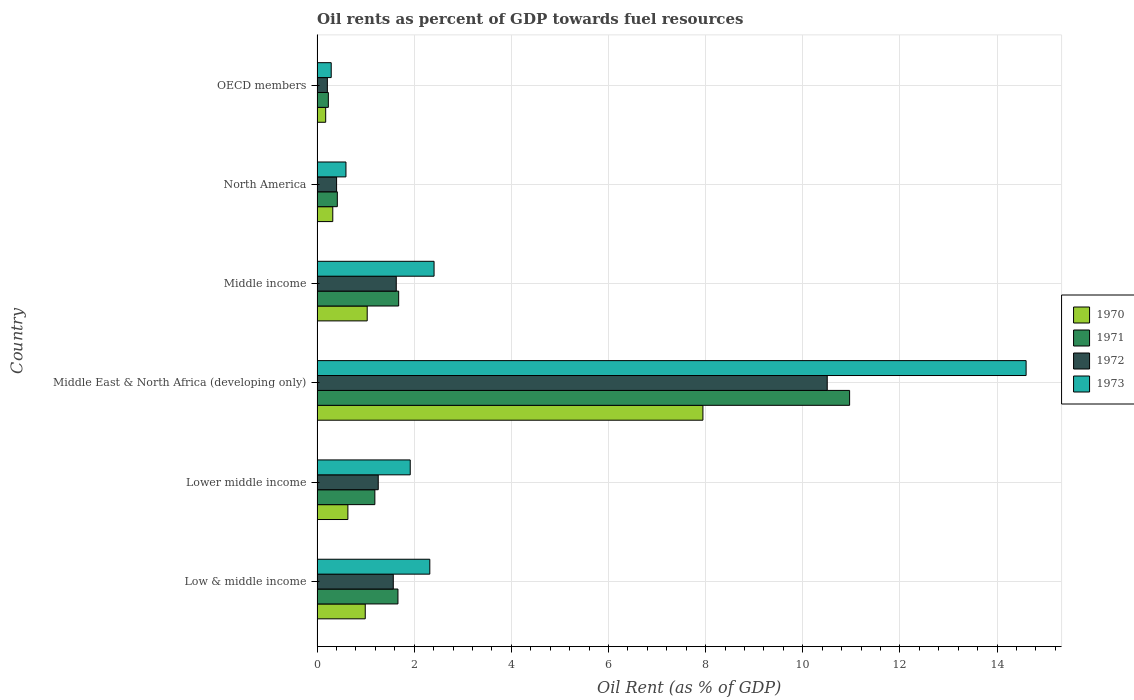How many different coloured bars are there?
Provide a succinct answer. 4. Are the number of bars per tick equal to the number of legend labels?
Provide a succinct answer. Yes. How many bars are there on the 3rd tick from the bottom?
Keep it short and to the point. 4. What is the label of the 1st group of bars from the top?
Offer a very short reply. OECD members. What is the oil rent in 1973 in Middle income?
Provide a succinct answer. 2.41. Across all countries, what is the maximum oil rent in 1970?
Offer a terse response. 7.94. Across all countries, what is the minimum oil rent in 1971?
Provide a short and direct response. 0.23. In which country was the oil rent in 1973 maximum?
Provide a short and direct response. Middle East & North Africa (developing only). What is the total oil rent in 1973 in the graph?
Your response must be concise. 22.13. What is the difference between the oil rent in 1972 in Middle East & North Africa (developing only) and that in OECD members?
Your answer should be compact. 10.29. What is the difference between the oil rent in 1973 in Lower middle income and the oil rent in 1972 in Low & middle income?
Provide a short and direct response. 0.35. What is the average oil rent in 1973 per country?
Your answer should be very brief. 3.69. What is the difference between the oil rent in 1972 and oil rent in 1970 in Low & middle income?
Your answer should be very brief. 0.58. In how many countries, is the oil rent in 1971 greater than 7.2 %?
Your answer should be compact. 1. What is the ratio of the oil rent in 1972 in Lower middle income to that in Middle income?
Keep it short and to the point. 0.77. What is the difference between the highest and the second highest oil rent in 1971?
Your answer should be very brief. 9.28. What is the difference between the highest and the lowest oil rent in 1972?
Your answer should be very brief. 10.29. In how many countries, is the oil rent in 1972 greater than the average oil rent in 1972 taken over all countries?
Your answer should be compact. 1. Is the sum of the oil rent in 1971 in Middle East & North Africa (developing only) and OECD members greater than the maximum oil rent in 1972 across all countries?
Keep it short and to the point. Yes. What does the 4th bar from the top in Lower middle income represents?
Offer a very short reply. 1970. Are all the bars in the graph horizontal?
Offer a terse response. Yes. What is the difference between two consecutive major ticks on the X-axis?
Your response must be concise. 2. Where does the legend appear in the graph?
Provide a short and direct response. Center right. What is the title of the graph?
Offer a very short reply. Oil rents as percent of GDP towards fuel resources. Does "2006" appear as one of the legend labels in the graph?
Ensure brevity in your answer.  No. What is the label or title of the X-axis?
Provide a succinct answer. Oil Rent (as % of GDP). What is the Oil Rent (as % of GDP) in 1970 in Low & middle income?
Provide a short and direct response. 0.99. What is the Oil Rent (as % of GDP) of 1971 in Low & middle income?
Provide a succinct answer. 1.67. What is the Oil Rent (as % of GDP) in 1972 in Low & middle income?
Your response must be concise. 1.57. What is the Oil Rent (as % of GDP) of 1973 in Low & middle income?
Provide a short and direct response. 2.32. What is the Oil Rent (as % of GDP) in 1970 in Lower middle income?
Your answer should be very brief. 0.63. What is the Oil Rent (as % of GDP) in 1971 in Lower middle income?
Offer a terse response. 1.19. What is the Oil Rent (as % of GDP) in 1972 in Lower middle income?
Offer a very short reply. 1.26. What is the Oil Rent (as % of GDP) of 1973 in Lower middle income?
Your answer should be very brief. 1.92. What is the Oil Rent (as % of GDP) of 1970 in Middle East & North Africa (developing only)?
Offer a terse response. 7.94. What is the Oil Rent (as % of GDP) in 1971 in Middle East & North Africa (developing only)?
Your answer should be compact. 10.96. What is the Oil Rent (as % of GDP) of 1972 in Middle East & North Africa (developing only)?
Offer a terse response. 10.5. What is the Oil Rent (as % of GDP) in 1973 in Middle East & North Africa (developing only)?
Your answer should be compact. 14.6. What is the Oil Rent (as % of GDP) in 1970 in Middle income?
Ensure brevity in your answer.  1.03. What is the Oil Rent (as % of GDP) in 1971 in Middle income?
Your answer should be compact. 1.68. What is the Oil Rent (as % of GDP) of 1972 in Middle income?
Your answer should be very brief. 1.63. What is the Oil Rent (as % of GDP) in 1973 in Middle income?
Provide a succinct answer. 2.41. What is the Oil Rent (as % of GDP) of 1970 in North America?
Your answer should be compact. 0.32. What is the Oil Rent (as % of GDP) in 1971 in North America?
Your answer should be very brief. 0.42. What is the Oil Rent (as % of GDP) in 1972 in North America?
Your answer should be very brief. 0.4. What is the Oil Rent (as % of GDP) in 1973 in North America?
Your answer should be compact. 0.6. What is the Oil Rent (as % of GDP) in 1970 in OECD members?
Offer a terse response. 0.18. What is the Oil Rent (as % of GDP) of 1971 in OECD members?
Provide a succinct answer. 0.23. What is the Oil Rent (as % of GDP) of 1972 in OECD members?
Give a very brief answer. 0.21. What is the Oil Rent (as % of GDP) in 1973 in OECD members?
Offer a very short reply. 0.29. Across all countries, what is the maximum Oil Rent (as % of GDP) of 1970?
Your answer should be very brief. 7.94. Across all countries, what is the maximum Oil Rent (as % of GDP) in 1971?
Provide a short and direct response. 10.96. Across all countries, what is the maximum Oil Rent (as % of GDP) in 1972?
Make the answer very short. 10.5. Across all countries, what is the maximum Oil Rent (as % of GDP) in 1973?
Offer a very short reply. 14.6. Across all countries, what is the minimum Oil Rent (as % of GDP) in 1970?
Give a very brief answer. 0.18. Across all countries, what is the minimum Oil Rent (as % of GDP) of 1971?
Your answer should be very brief. 0.23. Across all countries, what is the minimum Oil Rent (as % of GDP) in 1972?
Your response must be concise. 0.21. Across all countries, what is the minimum Oil Rent (as % of GDP) in 1973?
Your response must be concise. 0.29. What is the total Oil Rent (as % of GDP) in 1970 in the graph?
Keep it short and to the point. 11.1. What is the total Oil Rent (as % of GDP) of 1971 in the graph?
Your response must be concise. 16.15. What is the total Oil Rent (as % of GDP) of 1972 in the graph?
Your answer should be very brief. 15.58. What is the total Oil Rent (as % of GDP) of 1973 in the graph?
Make the answer very short. 22.13. What is the difference between the Oil Rent (as % of GDP) of 1970 in Low & middle income and that in Lower middle income?
Provide a succinct answer. 0.36. What is the difference between the Oil Rent (as % of GDP) of 1971 in Low & middle income and that in Lower middle income?
Provide a succinct answer. 0.48. What is the difference between the Oil Rent (as % of GDP) of 1972 in Low & middle income and that in Lower middle income?
Ensure brevity in your answer.  0.31. What is the difference between the Oil Rent (as % of GDP) in 1973 in Low & middle income and that in Lower middle income?
Your response must be concise. 0.4. What is the difference between the Oil Rent (as % of GDP) of 1970 in Low & middle income and that in Middle East & North Africa (developing only)?
Make the answer very short. -6.95. What is the difference between the Oil Rent (as % of GDP) in 1971 in Low & middle income and that in Middle East & North Africa (developing only)?
Ensure brevity in your answer.  -9.3. What is the difference between the Oil Rent (as % of GDP) of 1972 in Low & middle income and that in Middle East & North Africa (developing only)?
Ensure brevity in your answer.  -8.93. What is the difference between the Oil Rent (as % of GDP) in 1973 in Low & middle income and that in Middle East & North Africa (developing only)?
Offer a very short reply. -12.28. What is the difference between the Oil Rent (as % of GDP) in 1970 in Low & middle income and that in Middle income?
Provide a succinct answer. -0.04. What is the difference between the Oil Rent (as % of GDP) in 1971 in Low & middle income and that in Middle income?
Keep it short and to the point. -0.01. What is the difference between the Oil Rent (as % of GDP) of 1972 in Low & middle income and that in Middle income?
Offer a terse response. -0.06. What is the difference between the Oil Rent (as % of GDP) in 1973 in Low & middle income and that in Middle income?
Keep it short and to the point. -0.09. What is the difference between the Oil Rent (as % of GDP) in 1970 in Low & middle income and that in North America?
Make the answer very short. 0.67. What is the difference between the Oil Rent (as % of GDP) of 1971 in Low & middle income and that in North America?
Give a very brief answer. 1.25. What is the difference between the Oil Rent (as % of GDP) of 1972 in Low & middle income and that in North America?
Offer a very short reply. 1.17. What is the difference between the Oil Rent (as % of GDP) of 1973 in Low & middle income and that in North America?
Your response must be concise. 1.73. What is the difference between the Oil Rent (as % of GDP) in 1970 in Low & middle income and that in OECD members?
Make the answer very short. 0.81. What is the difference between the Oil Rent (as % of GDP) of 1971 in Low & middle income and that in OECD members?
Your answer should be compact. 1.43. What is the difference between the Oil Rent (as % of GDP) in 1972 in Low & middle income and that in OECD members?
Your answer should be very brief. 1.36. What is the difference between the Oil Rent (as % of GDP) in 1973 in Low & middle income and that in OECD members?
Your response must be concise. 2.03. What is the difference between the Oil Rent (as % of GDP) of 1970 in Lower middle income and that in Middle East & North Africa (developing only)?
Your response must be concise. -7.31. What is the difference between the Oil Rent (as % of GDP) of 1971 in Lower middle income and that in Middle East & North Africa (developing only)?
Provide a short and direct response. -9.77. What is the difference between the Oil Rent (as % of GDP) in 1972 in Lower middle income and that in Middle East & North Africa (developing only)?
Provide a succinct answer. -9.24. What is the difference between the Oil Rent (as % of GDP) of 1973 in Lower middle income and that in Middle East & North Africa (developing only)?
Make the answer very short. -12.68. What is the difference between the Oil Rent (as % of GDP) of 1970 in Lower middle income and that in Middle income?
Your response must be concise. -0.4. What is the difference between the Oil Rent (as % of GDP) in 1971 in Lower middle income and that in Middle income?
Ensure brevity in your answer.  -0.49. What is the difference between the Oil Rent (as % of GDP) of 1972 in Lower middle income and that in Middle income?
Keep it short and to the point. -0.37. What is the difference between the Oil Rent (as % of GDP) in 1973 in Lower middle income and that in Middle income?
Your answer should be compact. -0.49. What is the difference between the Oil Rent (as % of GDP) of 1970 in Lower middle income and that in North America?
Keep it short and to the point. 0.31. What is the difference between the Oil Rent (as % of GDP) of 1971 in Lower middle income and that in North America?
Offer a terse response. 0.77. What is the difference between the Oil Rent (as % of GDP) in 1972 in Lower middle income and that in North America?
Give a very brief answer. 0.86. What is the difference between the Oil Rent (as % of GDP) of 1973 in Lower middle income and that in North America?
Your response must be concise. 1.32. What is the difference between the Oil Rent (as % of GDP) in 1970 in Lower middle income and that in OECD members?
Your response must be concise. 0.46. What is the difference between the Oil Rent (as % of GDP) of 1971 in Lower middle income and that in OECD members?
Make the answer very short. 0.96. What is the difference between the Oil Rent (as % of GDP) in 1972 in Lower middle income and that in OECD members?
Ensure brevity in your answer.  1.05. What is the difference between the Oil Rent (as % of GDP) in 1973 in Lower middle income and that in OECD members?
Keep it short and to the point. 1.63. What is the difference between the Oil Rent (as % of GDP) in 1970 in Middle East & North Africa (developing only) and that in Middle income?
Ensure brevity in your answer.  6.91. What is the difference between the Oil Rent (as % of GDP) of 1971 in Middle East & North Africa (developing only) and that in Middle income?
Your answer should be compact. 9.28. What is the difference between the Oil Rent (as % of GDP) of 1972 in Middle East & North Africa (developing only) and that in Middle income?
Provide a short and direct response. 8.87. What is the difference between the Oil Rent (as % of GDP) of 1973 in Middle East & North Africa (developing only) and that in Middle income?
Give a very brief answer. 12.19. What is the difference between the Oil Rent (as % of GDP) in 1970 in Middle East & North Africa (developing only) and that in North America?
Offer a very short reply. 7.62. What is the difference between the Oil Rent (as % of GDP) in 1971 in Middle East & North Africa (developing only) and that in North America?
Keep it short and to the point. 10.55. What is the difference between the Oil Rent (as % of GDP) of 1972 in Middle East & North Africa (developing only) and that in North America?
Give a very brief answer. 10.1. What is the difference between the Oil Rent (as % of GDP) in 1973 in Middle East & North Africa (developing only) and that in North America?
Provide a short and direct response. 14. What is the difference between the Oil Rent (as % of GDP) of 1970 in Middle East & North Africa (developing only) and that in OECD members?
Offer a very short reply. 7.77. What is the difference between the Oil Rent (as % of GDP) in 1971 in Middle East & North Africa (developing only) and that in OECD members?
Offer a terse response. 10.73. What is the difference between the Oil Rent (as % of GDP) in 1972 in Middle East & North Africa (developing only) and that in OECD members?
Your answer should be compact. 10.29. What is the difference between the Oil Rent (as % of GDP) of 1973 in Middle East & North Africa (developing only) and that in OECD members?
Offer a very short reply. 14.3. What is the difference between the Oil Rent (as % of GDP) of 1970 in Middle income and that in North America?
Your answer should be very brief. 0.71. What is the difference between the Oil Rent (as % of GDP) of 1971 in Middle income and that in North America?
Your response must be concise. 1.26. What is the difference between the Oil Rent (as % of GDP) in 1972 in Middle income and that in North America?
Make the answer very short. 1.23. What is the difference between the Oil Rent (as % of GDP) of 1973 in Middle income and that in North America?
Provide a short and direct response. 1.81. What is the difference between the Oil Rent (as % of GDP) in 1970 in Middle income and that in OECD members?
Offer a very short reply. 0.85. What is the difference between the Oil Rent (as % of GDP) in 1971 in Middle income and that in OECD members?
Your response must be concise. 1.45. What is the difference between the Oil Rent (as % of GDP) of 1972 in Middle income and that in OECD members?
Offer a very short reply. 1.42. What is the difference between the Oil Rent (as % of GDP) in 1973 in Middle income and that in OECD members?
Keep it short and to the point. 2.12. What is the difference between the Oil Rent (as % of GDP) of 1970 in North America and that in OECD members?
Your response must be concise. 0.15. What is the difference between the Oil Rent (as % of GDP) of 1971 in North America and that in OECD members?
Offer a terse response. 0.18. What is the difference between the Oil Rent (as % of GDP) of 1972 in North America and that in OECD members?
Your answer should be compact. 0.19. What is the difference between the Oil Rent (as % of GDP) in 1973 in North America and that in OECD members?
Your answer should be very brief. 0.3. What is the difference between the Oil Rent (as % of GDP) of 1970 in Low & middle income and the Oil Rent (as % of GDP) of 1971 in Lower middle income?
Give a very brief answer. -0.2. What is the difference between the Oil Rent (as % of GDP) of 1970 in Low & middle income and the Oil Rent (as % of GDP) of 1972 in Lower middle income?
Provide a short and direct response. -0.27. What is the difference between the Oil Rent (as % of GDP) in 1970 in Low & middle income and the Oil Rent (as % of GDP) in 1973 in Lower middle income?
Your response must be concise. -0.93. What is the difference between the Oil Rent (as % of GDP) of 1971 in Low & middle income and the Oil Rent (as % of GDP) of 1972 in Lower middle income?
Your answer should be very brief. 0.41. What is the difference between the Oil Rent (as % of GDP) of 1971 in Low & middle income and the Oil Rent (as % of GDP) of 1973 in Lower middle income?
Ensure brevity in your answer.  -0.25. What is the difference between the Oil Rent (as % of GDP) of 1972 in Low & middle income and the Oil Rent (as % of GDP) of 1973 in Lower middle income?
Provide a succinct answer. -0.35. What is the difference between the Oil Rent (as % of GDP) of 1970 in Low & middle income and the Oil Rent (as % of GDP) of 1971 in Middle East & North Africa (developing only)?
Ensure brevity in your answer.  -9.97. What is the difference between the Oil Rent (as % of GDP) of 1970 in Low & middle income and the Oil Rent (as % of GDP) of 1972 in Middle East & North Africa (developing only)?
Offer a very short reply. -9.51. What is the difference between the Oil Rent (as % of GDP) in 1970 in Low & middle income and the Oil Rent (as % of GDP) in 1973 in Middle East & North Africa (developing only)?
Keep it short and to the point. -13.6. What is the difference between the Oil Rent (as % of GDP) of 1971 in Low & middle income and the Oil Rent (as % of GDP) of 1972 in Middle East & North Africa (developing only)?
Your response must be concise. -8.84. What is the difference between the Oil Rent (as % of GDP) in 1971 in Low & middle income and the Oil Rent (as % of GDP) in 1973 in Middle East & North Africa (developing only)?
Offer a very short reply. -12.93. What is the difference between the Oil Rent (as % of GDP) of 1972 in Low & middle income and the Oil Rent (as % of GDP) of 1973 in Middle East & North Africa (developing only)?
Keep it short and to the point. -13.03. What is the difference between the Oil Rent (as % of GDP) of 1970 in Low & middle income and the Oil Rent (as % of GDP) of 1971 in Middle income?
Your response must be concise. -0.69. What is the difference between the Oil Rent (as % of GDP) in 1970 in Low & middle income and the Oil Rent (as % of GDP) in 1972 in Middle income?
Your response must be concise. -0.64. What is the difference between the Oil Rent (as % of GDP) of 1970 in Low & middle income and the Oil Rent (as % of GDP) of 1973 in Middle income?
Your response must be concise. -1.42. What is the difference between the Oil Rent (as % of GDP) in 1971 in Low & middle income and the Oil Rent (as % of GDP) in 1972 in Middle income?
Provide a short and direct response. 0.03. What is the difference between the Oil Rent (as % of GDP) of 1971 in Low & middle income and the Oil Rent (as % of GDP) of 1973 in Middle income?
Make the answer very short. -0.74. What is the difference between the Oil Rent (as % of GDP) of 1972 in Low & middle income and the Oil Rent (as % of GDP) of 1973 in Middle income?
Provide a short and direct response. -0.84. What is the difference between the Oil Rent (as % of GDP) in 1970 in Low & middle income and the Oil Rent (as % of GDP) in 1971 in North America?
Offer a terse response. 0.57. What is the difference between the Oil Rent (as % of GDP) of 1970 in Low & middle income and the Oil Rent (as % of GDP) of 1972 in North America?
Your answer should be very brief. 0.59. What is the difference between the Oil Rent (as % of GDP) of 1970 in Low & middle income and the Oil Rent (as % of GDP) of 1973 in North America?
Make the answer very short. 0.4. What is the difference between the Oil Rent (as % of GDP) in 1971 in Low & middle income and the Oil Rent (as % of GDP) in 1972 in North America?
Make the answer very short. 1.26. What is the difference between the Oil Rent (as % of GDP) in 1971 in Low & middle income and the Oil Rent (as % of GDP) in 1973 in North America?
Give a very brief answer. 1.07. What is the difference between the Oil Rent (as % of GDP) of 1972 in Low & middle income and the Oil Rent (as % of GDP) of 1973 in North America?
Your response must be concise. 0.97. What is the difference between the Oil Rent (as % of GDP) in 1970 in Low & middle income and the Oil Rent (as % of GDP) in 1971 in OECD members?
Ensure brevity in your answer.  0.76. What is the difference between the Oil Rent (as % of GDP) in 1970 in Low & middle income and the Oil Rent (as % of GDP) in 1972 in OECD members?
Provide a short and direct response. 0.78. What is the difference between the Oil Rent (as % of GDP) of 1970 in Low & middle income and the Oil Rent (as % of GDP) of 1973 in OECD members?
Make the answer very short. 0.7. What is the difference between the Oil Rent (as % of GDP) of 1971 in Low & middle income and the Oil Rent (as % of GDP) of 1972 in OECD members?
Make the answer very short. 1.45. What is the difference between the Oil Rent (as % of GDP) in 1971 in Low & middle income and the Oil Rent (as % of GDP) in 1973 in OECD members?
Your answer should be compact. 1.37. What is the difference between the Oil Rent (as % of GDP) in 1972 in Low & middle income and the Oil Rent (as % of GDP) in 1973 in OECD members?
Offer a very short reply. 1.28. What is the difference between the Oil Rent (as % of GDP) of 1970 in Lower middle income and the Oil Rent (as % of GDP) of 1971 in Middle East & North Africa (developing only)?
Offer a terse response. -10.33. What is the difference between the Oil Rent (as % of GDP) in 1970 in Lower middle income and the Oil Rent (as % of GDP) in 1972 in Middle East & North Africa (developing only)?
Your response must be concise. -9.87. What is the difference between the Oil Rent (as % of GDP) in 1970 in Lower middle income and the Oil Rent (as % of GDP) in 1973 in Middle East & North Africa (developing only)?
Keep it short and to the point. -13.96. What is the difference between the Oil Rent (as % of GDP) in 1971 in Lower middle income and the Oil Rent (as % of GDP) in 1972 in Middle East & North Africa (developing only)?
Make the answer very short. -9.31. What is the difference between the Oil Rent (as % of GDP) in 1971 in Lower middle income and the Oil Rent (as % of GDP) in 1973 in Middle East & North Africa (developing only)?
Offer a terse response. -13.41. What is the difference between the Oil Rent (as % of GDP) in 1972 in Lower middle income and the Oil Rent (as % of GDP) in 1973 in Middle East & North Africa (developing only)?
Offer a terse response. -13.34. What is the difference between the Oil Rent (as % of GDP) in 1970 in Lower middle income and the Oil Rent (as % of GDP) in 1971 in Middle income?
Your answer should be very brief. -1.05. What is the difference between the Oil Rent (as % of GDP) of 1970 in Lower middle income and the Oil Rent (as % of GDP) of 1972 in Middle income?
Offer a very short reply. -1. What is the difference between the Oil Rent (as % of GDP) of 1970 in Lower middle income and the Oil Rent (as % of GDP) of 1973 in Middle income?
Offer a terse response. -1.77. What is the difference between the Oil Rent (as % of GDP) of 1971 in Lower middle income and the Oil Rent (as % of GDP) of 1972 in Middle income?
Offer a very short reply. -0.44. What is the difference between the Oil Rent (as % of GDP) in 1971 in Lower middle income and the Oil Rent (as % of GDP) in 1973 in Middle income?
Keep it short and to the point. -1.22. What is the difference between the Oil Rent (as % of GDP) in 1972 in Lower middle income and the Oil Rent (as % of GDP) in 1973 in Middle income?
Provide a short and direct response. -1.15. What is the difference between the Oil Rent (as % of GDP) in 1970 in Lower middle income and the Oil Rent (as % of GDP) in 1971 in North America?
Keep it short and to the point. 0.22. What is the difference between the Oil Rent (as % of GDP) in 1970 in Lower middle income and the Oil Rent (as % of GDP) in 1972 in North America?
Your answer should be very brief. 0.23. What is the difference between the Oil Rent (as % of GDP) of 1970 in Lower middle income and the Oil Rent (as % of GDP) of 1973 in North America?
Offer a very short reply. 0.04. What is the difference between the Oil Rent (as % of GDP) in 1971 in Lower middle income and the Oil Rent (as % of GDP) in 1972 in North America?
Offer a very short reply. 0.79. What is the difference between the Oil Rent (as % of GDP) in 1971 in Lower middle income and the Oil Rent (as % of GDP) in 1973 in North America?
Ensure brevity in your answer.  0.6. What is the difference between the Oil Rent (as % of GDP) of 1972 in Lower middle income and the Oil Rent (as % of GDP) of 1973 in North America?
Provide a short and direct response. 0.66. What is the difference between the Oil Rent (as % of GDP) in 1970 in Lower middle income and the Oil Rent (as % of GDP) in 1971 in OECD members?
Provide a succinct answer. 0.4. What is the difference between the Oil Rent (as % of GDP) of 1970 in Lower middle income and the Oil Rent (as % of GDP) of 1972 in OECD members?
Offer a terse response. 0.42. What is the difference between the Oil Rent (as % of GDP) of 1970 in Lower middle income and the Oil Rent (as % of GDP) of 1973 in OECD members?
Make the answer very short. 0.34. What is the difference between the Oil Rent (as % of GDP) of 1971 in Lower middle income and the Oil Rent (as % of GDP) of 1972 in OECD members?
Provide a short and direct response. 0.98. What is the difference between the Oil Rent (as % of GDP) in 1971 in Lower middle income and the Oil Rent (as % of GDP) in 1973 in OECD members?
Your answer should be very brief. 0.9. What is the difference between the Oil Rent (as % of GDP) of 1972 in Lower middle income and the Oil Rent (as % of GDP) of 1973 in OECD members?
Make the answer very short. 0.97. What is the difference between the Oil Rent (as % of GDP) of 1970 in Middle East & North Africa (developing only) and the Oil Rent (as % of GDP) of 1971 in Middle income?
Give a very brief answer. 6.26. What is the difference between the Oil Rent (as % of GDP) of 1970 in Middle East & North Africa (developing only) and the Oil Rent (as % of GDP) of 1972 in Middle income?
Your answer should be very brief. 6.31. What is the difference between the Oil Rent (as % of GDP) in 1970 in Middle East & North Africa (developing only) and the Oil Rent (as % of GDP) in 1973 in Middle income?
Give a very brief answer. 5.53. What is the difference between the Oil Rent (as % of GDP) in 1971 in Middle East & North Africa (developing only) and the Oil Rent (as % of GDP) in 1972 in Middle income?
Provide a succinct answer. 9.33. What is the difference between the Oil Rent (as % of GDP) of 1971 in Middle East & North Africa (developing only) and the Oil Rent (as % of GDP) of 1973 in Middle income?
Your response must be concise. 8.55. What is the difference between the Oil Rent (as % of GDP) of 1972 in Middle East & North Africa (developing only) and the Oil Rent (as % of GDP) of 1973 in Middle income?
Your answer should be very brief. 8.09. What is the difference between the Oil Rent (as % of GDP) in 1970 in Middle East & North Africa (developing only) and the Oil Rent (as % of GDP) in 1971 in North America?
Offer a terse response. 7.53. What is the difference between the Oil Rent (as % of GDP) of 1970 in Middle East & North Africa (developing only) and the Oil Rent (as % of GDP) of 1972 in North America?
Provide a short and direct response. 7.54. What is the difference between the Oil Rent (as % of GDP) of 1970 in Middle East & North Africa (developing only) and the Oil Rent (as % of GDP) of 1973 in North America?
Your answer should be very brief. 7.35. What is the difference between the Oil Rent (as % of GDP) in 1971 in Middle East & North Africa (developing only) and the Oil Rent (as % of GDP) in 1972 in North America?
Your answer should be compact. 10.56. What is the difference between the Oil Rent (as % of GDP) of 1971 in Middle East & North Africa (developing only) and the Oil Rent (as % of GDP) of 1973 in North America?
Ensure brevity in your answer.  10.37. What is the difference between the Oil Rent (as % of GDP) in 1972 in Middle East & North Africa (developing only) and the Oil Rent (as % of GDP) in 1973 in North America?
Your answer should be compact. 9.91. What is the difference between the Oil Rent (as % of GDP) of 1970 in Middle East & North Africa (developing only) and the Oil Rent (as % of GDP) of 1971 in OECD members?
Offer a very short reply. 7.71. What is the difference between the Oil Rent (as % of GDP) in 1970 in Middle East & North Africa (developing only) and the Oil Rent (as % of GDP) in 1972 in OECD members?
Give a very brief answer. 7.73. What is the difference between the Oil Rent (as % of GDP) in 1970 in Middle East & North Africa (developing only) and the Oil Rent (as % of GDP) in 1973 in OECD members?
Your answer should be very brief. 7.65. What is the difference between the Oil Rent (as % of GDP) of 1971 in Middle East & North Africa (developing only) and the Oil Rent (as % of GDP) of 1972 in OECD members?
Offer a very short reply. 10.75. What is the difference between the Oil Rent (as % of GDP) in 1971 in Middle East & North Africa (developing only) and the Oil Rent (as % of GDP) in 1973 in OECD members?
Your response must be concise. 10.67. What is the difference between the Oil Rent (as % of GDP) in 1972 in Middle East & North Africa (developing only) and the Oil Rent (as % of GDP) in 1973 in OECD members?
Give a very brief answer. 10.21. What is the difference between the Oil Rent (as % of GDP) in 1970 in Middle income and the Oil Rent (as % of GDP) in 1971 in North America?
Keep it short and to the point. 0.61. What is the difference between the Oil Rent (as % of GDP) in 1970 in Middle income and the Oil Rent (as % of GDP) in 1972 in North America?
Give a very brief answer. 0.63. What is the difference between the Oil Rent (as % of GDP) in 1970 in Middle income and the Oil Rent (as % of GDP) in 1973 in North America?
Keep it short and to the point. 0.44. What is the difference between the Oil Rent (as % of GDP) of 1971 in Middle income and the Oil Rent (as % of GDP) of 1972 in North America?
Ensure brevity in your answer.  1.28. What is the difference between the Oil Rent (as % of GDP) of 1971 in Middle income and the Oil Rent (as % of GDP) of 1973 in North America?
Your response must be concise. 1.09. What is the difference between the Oil Rent (as % of GDP) in 1972 in Middle income and the Oil Rent (as % of GDP) in 1973 in North America?
Provide a short and direct response. 1.04. What is the difference between the Oil Rent (as % of GDP) in 1970 in Middle income and the Oil Rent (as % of GDP) in 1971 in OECD members?
Offer a very short reply. 0.8. What is the difference between the Oil Rent (as % of GDP) of 1970 in Middle income and the Oil Rent (as % of GDP) of 1972 in OECD members?
Ensure brevity in your answer.  0.82. What is the difference between the Oil Rent (as % of GDP) in 1970 in Middle income and the Oil Rent (as % of GDP) in 1973 in OECD members?
Your answer should be very brief. 0.74. What is the difference between the Oil Rent (as % of GDP) in 1971 in Middle income and the Oil Rent (as % of GDP) in 1972 in OECD members?
Offer a very short reply. 1.47. What is the difference between the Oil Rent (as % of GDP) in 1971 in Middle income and the Oil Rent (as % of GDP) in 1973 in OECD members?
Give a very brief answer. 1.39. What is the difference between the Oil Rent (as % of GDP) in 1972 in Middle income and the Oil Rent (as % of GDP) in 1973 in OECD members?
Provide a short and direct response. 1.34. What is the difference between the Oil Rent (as % of GDP) in 1970 in North America and the Oil Rent (as % of GDP) in 1971 in OECD members?
Ensure brevity in your answer.  0.09. What is the difference between the Oil Rent (as % of GDP) of 1970 in North America and the Oil Rent (as % of GDP) of 1972 in OECD members?
Offer a very short reply. 0.11. What is the difference between the Oil Rent (as % of GDP) of 1970 in North America and the Oil Rent (as % of GDP) of 1973 in OECD members?
Offer a terse response. 0.03. What is the difference between the Oil Rent (as % of GDP) in 1971 in North America and the Oil Rent (as % of GDP) in 1972 in OECD members?
Provide a succinct answer. 0.21. What is the difference between the Oil Rent (as % of GDP) in 1971 in North America and the Oil Rent (as % of GDP) in 1973 in OECD members?
Make the answer very short. 0.13. What is the difference between the Oil Rent (as % of GDP) of 1972 in North America and the Oil Rent (as % of GDP) of 1973 in OECD members?
Your answer should be very brief. 0.11. What is the average Oil Rent (as % of GDP) of 1970 per country?
Provide a succinct answer. 1.85. What is the average Oil Rent (as % of GDP) in 1971 per country?
Your answer should be compact. 2.69. What is the average Oil Rent (as % of GDP) of 1972 per country?
Your response must be concise. 2.6. What is the average Oil Rent (as % of GDP) in 1973 per country?
Provide a succinct answer. 3.69. What is the difference between the Oil Rent (as % of GDP) of 1970 and Oil Rent (as % of GDP) of 1971 in Low & middle income?
Make the answer very short. -0.67. What is the difference between the Oil Rent (as % of GDP) of 1970 and Oil Rent (as % of GDP) of 1972 in Low & middle income?
Offer a very short reply. -0.58. What is the difference between the Oil Rent (as % of GDP) of 1970 and Oil Rent (as % of GDP) of 1973 in Low & middle income?
Give a very brief answer. -1.33. What is the difference between the Oil Rent (as % of GDP) of 1971 and Oil Rent (as % of GDP) of 1972 in Low & middle income?
Offer a terse response. 0.1. What is the difference between the Oil Rent (as % of GDP) in 1971 and Oil Rent (as % of GDP) in 1973 in Low & middle income?
Your response must be concise. -0.66. What is the difference between the Oil Rent (as % of GDP) of 1972 and Oil Rent (as % of GDP) of 1973 in Low & middle income?
Your answer should be compact. -0.75. What is the difference between the Oil Rent (as % of GDP) of 1970 and Oil Rent (as % of GDP) of 1971 in Lower middle income?
Keep it short and to the point. -0.56. What is the difference between the Oil Rent (as % of GDP) of 1970 and Oil Rent (as % of GDP) of 1972 in Lower middle income?
Your response must be concise. -0.62. What is the difference between the Oil Rent (as % of GDP) of 1970 and Oil Rent (as % of GDP) of 1973 in Lower middle income?
Your answer should be compact. -1.28. What is the difference between the Oil Rent (as % of GDP) in 1971 and Oil Rent (as % of GDP) in 1972 in Lower middle income?
Your response must be concise. -0.07. What is the difference between the Oil Rent (as % of GDP) in 1971 and Oil Rent (as % of GDP) in 1973 in Lower middle income?
Provide a short and direct response. -0.73. What is the difference between the Oil Rent (as % of GDP) of 1972 and Oil Rent (as % of GDP) of 1973 in Lower middle income?
Make the answer very short. -0.66. What is the difference between the Oil Rent (as % of GDP) in 1970 and Oil Rent (as % of GDP) in 1971 in Middle East & North Africa (developing only)?
Keep it short and to the point. -3.02. What is the difference between the Oil Rent (as % of GDP) of 1970 and Oil Rent (as % of GDP) of 1972 in Middle East & North Africa (developing only)?
Ensure brevity in your answer.  -2.56. What is the difference between the Oil Rent (as % of GDP) of 1970 and Oil Rent (as % of GDP) of 1973 in Middle East & North Africa (developing only)?
Provide a short and direct response. -6.65. What is the difference between the Oil Rent (as % of GDP) in 1971 and Oil Rent (as % of GDP) in 1972 in Middle East & North Africa (developing only)?
Your answer should be compact. 0.46. What is the difference between the Oil Rent (as % of GDP) of 1971 and Oil Rent (as % of GDP) of 1973 in Middle East & North Africa (developing only)?
Keep it short and to the point. -3.63. What is the difference between the Oil Rent (as % of GDP) of 1972 and Oil Rent (as % of GDP) of 1973 in Middle East & North Africa (developing only)?
Keep it short and to the point. -4.09. What is the difference between the Oil Rent (as % of GDP) in 1970 and Oil Rent (as % of GDP) in 1971 in Middle income?
Offer a very short reply. -0.65. What is the difference between the Oil Rent (as % of GDP) in 1970 and Oil Rent (as % of GDP) in 1972 in Middle income?
Offer a very short reply. -0.6. What is the difference between the Oil Rent (as % of GDP) in 1970 and Oil Rent (as % of GDP) in 1973 in Middle income?
Offer a very short reply. -1.38. What is the difference between the Oil Rent (as % of GDP) in 1971 and Oil Rent (as % of GDP) in 1972 in Middle income?
Your response must be concise. 0.05. What is the difference between the Oil Rent (as % of GDP) in 1971 and Oil Rent (as % of GDP) in 1973 in Middle income?
Your response must be concise. -0.73. What is the difference between the Oil Rent (as % of GDP) of 1972 and Oil Rent (as % of GDP) of 1973 in Middle income?
Keep it short and to the point. -0.78. What is the difference between the Oil Rent (as % of GDP) in 1970 and Oil Rent (as % of GDP) in 1971 in North America?
Offer a terse response. -0.09. What is the difference between the Oil Rent (as % of GDP) in 1970 and Oil Rent (as % of GDP) in 1972 in North America?
Your answer should be compact. -0.08. What is the difference between the Oil Rent (as % of GDP) in 1970 and Oil Rent (as % of GDP) in 1973 in North America?
Provide a short and direct response. -0.27. What is the difference between the Oil Rent (as % of GDP) in 1971 and Oil Rent (as % of GDP) in 1972 in North America?
Provide a succinct answer. 0.02. What is the difference between the Oil Rent (as % of GDP) of 1971 and Oil Rent (as % of GDP) of 1973 in North America?
Keep it short and to the point. -0.18. What is the difference between the Oil Rent (as % of GDP) of 1972 and Oil Rent (as % of GDP) of 1973 in North America?
Your answer should be compact. -0.19. What is the difference between the Oil Rent (as % of GDP) in 1970 and Oil Rent (as % of GDP) in 1971 in OECD members?
Give a very brief answer. -0.05. What is the difference between the Oil Rent (as % of GDP) in 1970 and Oil Rent (as % of GDP) in 1972 in OECD members?
Make the answer very short. -0.03. What is the difference between the Oil Rent (as % of GDP) in 1970 and Oil Rent (as % of GDP) in 1973 in OECD members?
Offer a very short reply. -0.11. What is the difference between the Oil Rent (as % of GDP) in 1971 and Oil Rent (as % of GDP) in 1972 in OECD members?
Ensure brevity in your answer.  0.02. What is the difference between the Oil Rent (as % of GDP) of 1971 and Oil Rent (as % of GDP) of 1973 in OECD members?
Offer a very short reply. -0.06. What is the difference between the Oil Rent (as % of GDP) in 1972 and Oil Rent (as % of GDP) in 1973 in OECD members?
Offer a terse response. -0.08. What is the ratio of the Oil Rent (as % of GDP) in 1970 in Low & middle income to that in Lower middle income?
Make the answer very short. 1.56. What is the ratio of the Oil Rent (as % of GDP) in 1971 in Low & middle income to that in Lower middle income?
Give a very brief answer. 1.4. What is the ratio of the Oil Rent (as % of GDP) in 1972 in Low & middle income to that in Lower middle income?
Your answer should be very brief. 1.25. What is the ratio of the Oil Rent (as % of GDP) of 1973 in Low & middle income to that in Lower middle income?
Ensure brevity in your answer.  1.21. What is the ratio of the Oil Rent (as % of GDP) of 1970 in Low & middle income to that in Middle East & North Africa (developing only)?
Your response must be concise. 0.12. What is the ratio of the Oil Rent (as % of GDP) of 1971 in Low & middle income to that in Middle East & North Africa (developing only)?
Provide a succinct answer. 0.15. What is the ratio of the Oil Rent (as % of GDP) in 1972 in Low & middle income to that in Middle East & North Africa (developing only)?
Your answer should be compact. 0.15. What is the ratio of the Oil Rent (as % of GDP) of 1973 in Low & middle income to that in Middle East & North Africa (developing only)?
Offer a terse response. 0.16. What is the ratio of the Oil Rent (as % of GDP) in 1970 in Low & middle income to that in Middle income?
Ensure brevity in your answer.  0.96. What is the ratio of the Oil Rent (as % of GDP) in 1972 in Low & middle income to that in Middle income?
Offer a very short reply. 0.96. What is the ratio of the Oil Rent (as % of GDP) in 1973 in Low & middle income to that in Middle income?
Ensure brevity in your answer.  0.96. What is the ratio of the Oil Rent (as % of GDP) in 1970 in Low & middle income to that in North America?
Keep it short and to the point. 3.07. What is the ratio of the Oil Rent (as % of GDP) in 1971 in Low & middle income to that in North America?
Give a very brief answer. 3.99. What is the ratio of the Oil Rent (as % of GDP) of 1972 in Low & middle income to that in North America?
Keep it short and to the point. 3.9. What is the ratio of the Oil Rent (as % of GDP) in 1973 in Low & middle income to that in North America?
Provide a succinct answer. 3.9. What is the ratio of the Oil Rent (as % of GDP) in 1970 in Low & middle income to that in OECD members?
Provide a short and direct response. 5.58. What is the ratio of the Oil Rent (as % of GDP) of 1971 in Low & middle income to that in OECD members?
Give a very brief answer. 7.16. What is the ratio of the Oil Rent (as % of GDP) in 1972 in Low & middle income to that in OECD members?
Keep it short and to the point. 7.39. What is the ratio of the Oil Rent (as % of GDP) in 1973 in Low & middle income to that in OECD members?
Your answer should be compact. 7.96. What is the ratio of the Oil Rent (as % of GDP) in 1970 in Lower middle income to that in Middle East & North Africa (developing only)?
Ensure brevity in your answer.  0.08. What is the ratio of the Oil Rent (as % of GDP) of 1971 in Lower middle income to that in Middle East & North Africa (developing only)?
Give a very brief answer. 0.11. What is the ratio of the Oil Rent (as % of GDP) in 1972 in Lower middle income to that in Middle East & North Africa (developing only)?
Offer a very short reply. 0.12. What is the ratio of the Oil Rent (as % of GDP) of 1973 in Lower middle income to that in Middle East & North Africa (developing only)?
Ensure brevity in your answer.  0.13. What is the ratio of the Oil Rent (as % of GDP) of 1970 in Lower middle income to that in Middle income?
Your answer should be compact. 0.61. What is the ratio of the Oil Rent (as % of GDP) in 1971 in Lower middle income to that in Middle income?
Offer a very short reply. 0.71. What is the ratio of the Oil Rent (as % of GDP) of 1972 in Lower middle income to that in Middle income?
Offer a very short reply. 0.77. What is the ratio of the Oil Rent (as % of GDP) of 1973 in Lower middle income to that in Middle income?
Your answer should be very brief. 0.8. What is the ratio of the Oil Rent (as % of GDP) in 1970 in Lower middle income to that in North America?
Make the answer very short. 1.96. What is the ratio of the Oil Rent (as % of GDP) in 1971 in Lower middle income to that in North America?
Ensure brevity in your answer.  2.85. What is the ratio of the Oil Rent (as % of GDP) of 1972 in Lower middle income to that in North America?
Make the answer very short. 3.13. What is the ratio of the Oil Rent (as % of GDP) in 1973 in Lower middle income to that in North America?
Give a very brief answer. 3.22. What is the ratio of the Oil Rent (as % of GDP) in 1970 in Lower middle income to that in OECD members?
Make the answer very short. 3.57. What is the ratio of the Oil Rent (as % of GDP) in 1971 in Lower middle income to that in OECD members?
Provide a short and direct response. 5.12. What is the ratio of the Oil Rent (as % of GDP) of 1972 in Lower middle income to that in OECD members?
Keep it short and to the point. 5.94. What is the ratio of the Oil Rent (as % of GDP) in 1973 in Lower middle income to that in OECD members?
Your answer should be compact. 6.58. What is the ratio of the Oil Rent (as % of GDP) of 1970 in Middle East & North Africa (developing only) to that in Middle income?
Give a very brief answer. 7.69. What is the ratio of the Oil Rent (as % of GDP) of 1971 in Middle East & North Africa (developing only) to that in Middle income?
Ensure brevity in your answer.  6.52. What is the ratio of the Oil Rent (as % of GDP) in 1972 in Middle East & North Africa (developing only) to that in Middle income?
Your response must be concise. 6.44. What is the ratio of the Oil Rent (as % of GDP) of 1973 in Middle East & North Africa (developing only) to that in Middle income?
Your answer should be very brief. 6.06. What is the ratio of the Oil Rent (as % of GDP) of 1970 in Middle East & North Africa (developing only) to that in North America?
Provide a succinct answer. 24.54. What is the ratio of the Oil Rent (as % of GDP) of 1971 in Middle East & North Africa (developing only) to that in North America?
Keep it short and to the point. 26.26. What is the ratio of the Oil Rent (as % of GDP) of 1972 in Middle East & North Africa (developing only) to that in North America?
Keep it short and to the point. 26.11. What is the ratio of the Oil Rent (as % of GDP) of 1973 in Middle East & North Africa (developing only) to that in North America?
Make the answer very short. 24.53. What is the ratio of the Oil Rent (as % of GDP) of 1970 in Middle East & North Africa (developing only) to that in OECD members?
Offer a terse response. 44.68. What is the ratio of the Oil Rent (as % of GDP) in 1971 in Middle East & North Africa (developing only) to that in OECD members?
Keep it short and to the point. 47.15. What is the ratio of the Oil Rent (as % of GDP) in 1972 in Middle East & North Africa (developing only) to that in OECD members?
Your answer should be compact. 49.49. What is the ratio of the Oil Rent (as % of GDP) in 1973 in Middle East & North Africa (developing only) to that in OECD members?
Your response must be concise. 50.04. What is the ratio of the Oil Rent (as % of GDP) in 1970 in Middle income to that in North America?
Offer a terse response. 3.19. What is the ratio of the Oil Rent (as % of GDP) in 1971 in Middle income to that in North America?
Ensure brevity in your answer.  4.03. What is the ratio of the Oil Rent (as % of GDP) of 1972 in Middle income to that in North America?
Make the answer very short. 4.05. What is the ratio of the Oil Rent (as % of GDP) in 1973 in Middle income to that in North America?
Provide a succinct answer. 4.05. What is the ratio of the Oil Rent (as % of GDP) in 1970 in Middle income to that in OECD members?
Provide a short and direct response. 5.81. What is the ratio of the Oil Rent (as % of GDP) of 1971 in Middle income to that in OECD members?
Your answer should be very brief. 7.23. What is the ratio of the Oil Rent (as % of GDP) of 1972 in Middle income to that in OECD members?
Provide a short and direct response. 7.68. What is the ratio of the Oil Rent (as % of GDP) of 1973 in Middle income to that in OECD members?
Your answer should be very brief. 8.26. What is the ratio of the Oil Rent (as % of GDP) in 1970 in North America to that in OECD members?
Your answer should be compact. 1.82. What is the ratio of the Oil Rent (as % of GDP) of 1971 in North America to that in OECD members?
Give a very brief answer. 1.8. What is the ratio of the Oil Rent (as % of GDP) in 1972 in North America to that in OECD members?
Your response must be concise. 1.9. What is the ratio of the Oil Rent (as % of GDP) of 1973 in North America to that in OECD members?
Your answer should be compact. 2.04. What is the difference between the highest and the second highest Oil Rent (as % of GDP) in 1970?
Keep it short and to the point. 6.91. What is the difference between the highest and the second highest Oil Rent (as % of GDP) of 1971?
Provide a succinct answer. 9.28. What is the difference between the highest and the second highest Oil Rent (as % of GDP) in 1972?
Your answer should be very brief. 8.87. What is the difference between the highest and the second highest Oil Rent (as % of GDP) in 1973?
Your answer should be very brief. 12.19. What is the difference between the highest and the lowest Oil Rent (as % of GDP) in 1970?
Provide a succinct answer. 7.77. What is the difference between the highest and the lowest Oil Rent (as % of GDP) of 1971?
Your response must be concise. 10.73. What is the difference between the highest and the lowest Oil Rent (as % of GDP) of 1972?
Make the answer very short. 10.29. What is the difference between the highest and the lowest Oil Rent (as % of GDP) in 1973?
Your answer should be very brief. 14.3. 